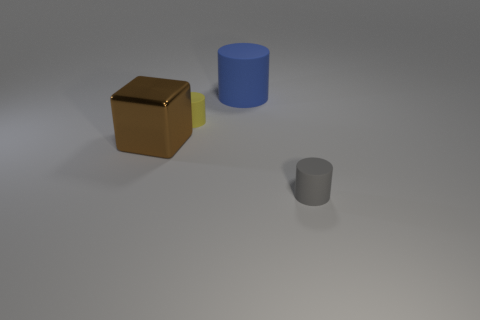How many matte objects are the same color as the metal object?
Offer a very short reply. 0. What number of balls are small gray things or shiny things?
Provide a succinct answer. 0. There is a rubber thing that is the same size as the yellow matte cylinder; what color is it?
Give a very brief answer. Gray. There is a big brown shiny cube on the left side of the gray rubber thing right of the brown shiny block; are there any matte cylinders right of it?
Keep it short and to the point. Yes. What size is the brown thing?
Keep it short and to the point. Large. How many things are either large blue rubber spheres or big blue things?
Your response must be concise. 1. What color is the big thing that is made of the same material as the tiny gray cylinder?
Offer a very short reply. Blue. There is a tiny matte object that is behind the tiny gray matte cylinder; is it the same shape as the big matte thing?
Ensure brevity in your answer.  Yes. What number of things are either objects in front of the blue cylinder or rubber cylinders behind the tiny gray object?
Offer a very short reply. 4. The other tiny rubber thing that is the same shape as the gray thing is what color?
Offer a very short reply. Yellow. 